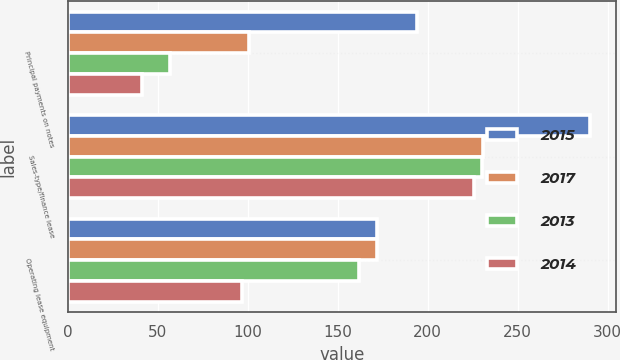Convert chart to OTSL. <chart><loc_0><loc_0><loc_500><loc_500><stacked_bar_chart><ecel><fcel>Principal payments on notes<fcel>Sales-type/finance lease<fcel>Operating lease equipment<nl><fcel>2015<fcel>194<fcel>290<fcel>172<nl><fcel>2017<fcel>101<fcel>231<fcel>172<nl><fcel>2013<fcel>57<fcel>230<fcel>162<nl><fcel>2014<fcel>41<fcel>226<fcel>97<nl></chart> 